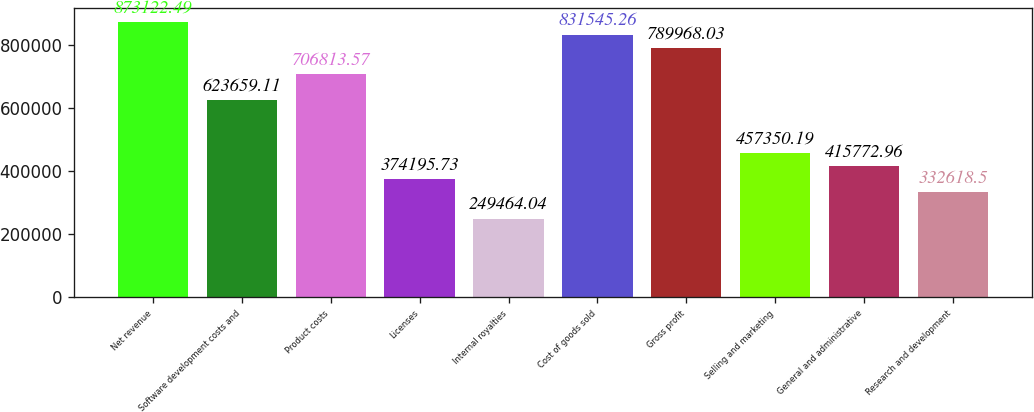Convert chart. <chart><loc_0><loc_0><loc_500><loc_500><bar_chart><fcel>Net revenue<fcel>Software development costs and<fcel>Product costs<fcel>Licenses<fcel>Internal royalties<fcel>Cost of goods sold<fcel>Gross profit<fcel>Selling and marketing<fcel>General and administrative<fcel>Research and development<nl><fcel>873122<fcel>623659<fcel>706814<fcel>374196<fcel>249464<fcel>831545<fcel>789968<fcel>457350<fcel>415773<fcel>332618<nl></chart> 